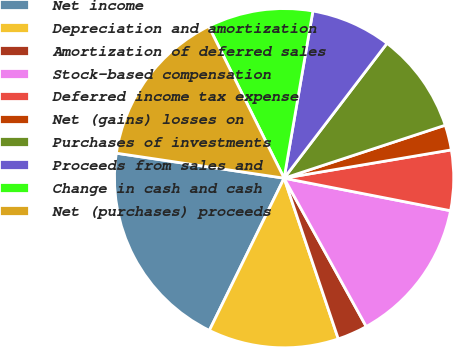<chart> <loc_0><loc_0><loc_500><loc_500><pie_chart><fcel>Net income<fcel>Depreciation and amortization<fcel>Amortization of deferred sales<fcel>Stock-based compensation<fcel>Deferred income tax expense<fcel>Net (gains) losses on<fcel>Purchases of investments<fcel>Proceeds from sales and<fcel>Change in cash and cash<fcel>Net (purchases) proceeds<nl><fcel>20.09%<fcel>12.44%<fcel>2.87%<fcel>13.88%<fcel>5.74%<fcel>2.39%<fcel>9.57%<fcel>7.66%<fcel>10.05%<fcel>15.31%<nl></chart> 